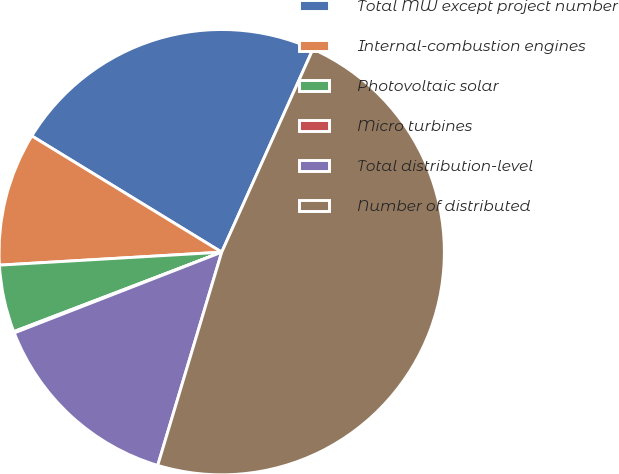<chart> <loc_0><loc_0><loc_500><loc_500><pie_chart><fcel>Total MW except project number<fcel>Internal-combustion engines<fcel>Photovoltaic solar<fcel>Micro turbines<fcel>Total distribution-level<fcel>Number of distributed<nl><fcel>22.98%<fcel>9.67%<fcel>4.88%<fcel>0.1%<fcel>14.45%<fcel>47.92%<nl></chart> 